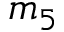Convert formula to latex. <formula><loc_0><loc_0><loc_500><loc_500>m _ { 5 }</formula> 